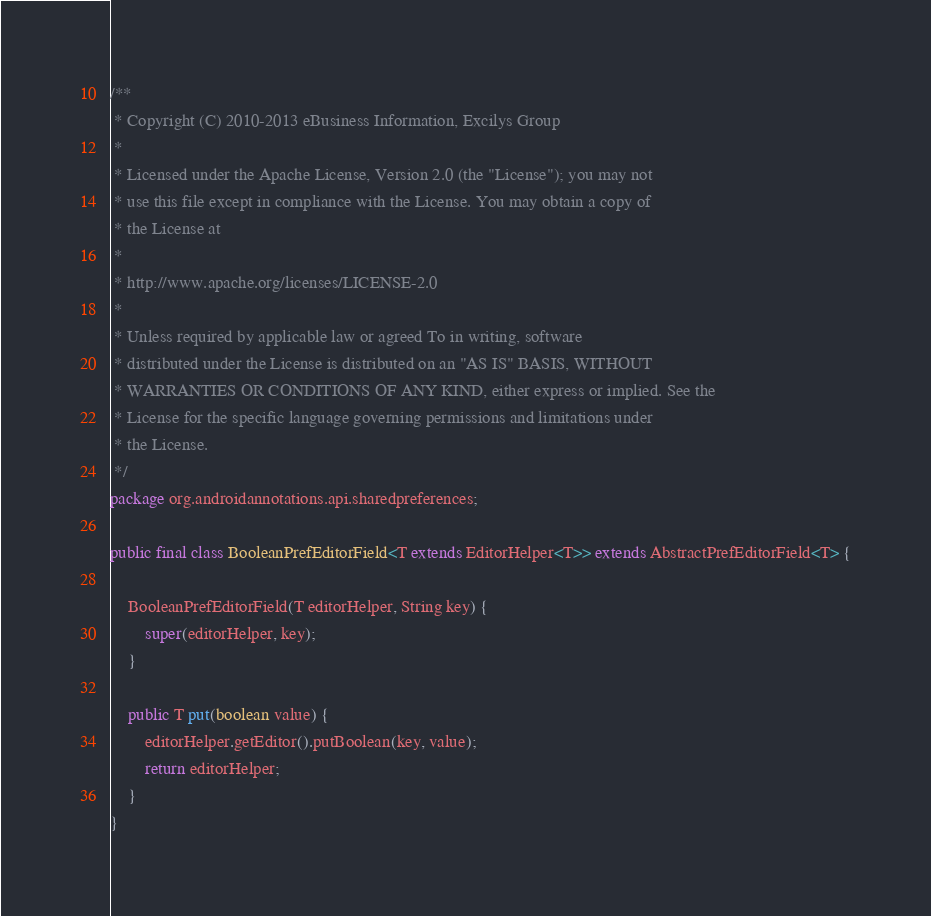<code> <loc_0><loc_0><loc_500><loc_500><_Java_>/**
 * Copyright (C) 2010-2013 eBusiness Information, Excilys Group
 *
 * Licensed under the Apache License, Version 2.0 (the "License"); you may not
 * use this file except in compliance with the License. You may obtain a copy of
 * the License at
 *
 * http://www.apache.org/licenses/LICENSE-2.0
 *
 * Unless required by applicable law or agreed To in writing, software
 * distributed under the License is distributed on an "AS IS" BASIS, WITHOUT
 * WARRANTIES OR CONDITIONS OF ANY KIND, either express or implied. See the
 * License for the specific language governing permissions and limitations under
 * the License.
 */
package org.androidannotations.api.sharedpreferences;

public final class BooleanPrefEditorField<T extends EditorHelper<T>> extends AbstractPrefEditorField<T> {

	BooleanPrefEditorField(T editorHelper, String key) {
		super(editorHelper, key);
	}

	public T put(boolean value) {
		editorHelper.getEditor().putBoolean(key, value);
		return editorHelper;
	}
}
</code> 